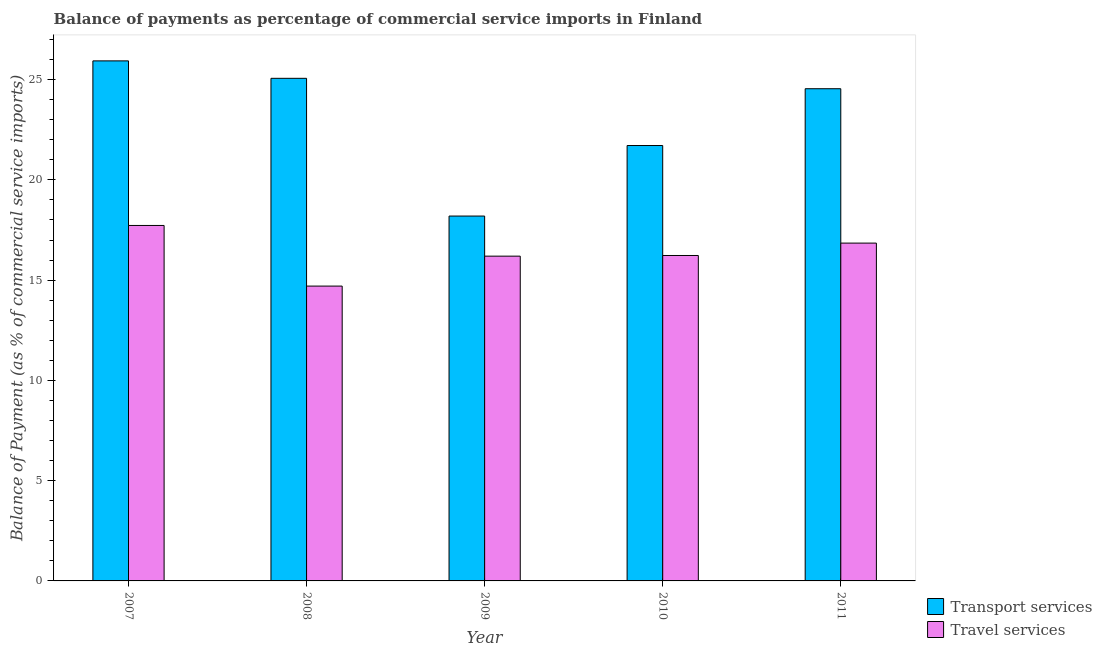How many bars are there on the 2nd tick from the right?
Your answer should be compact. 2. What is the label of the 4th group of bars from the left?
Give a very brief answer. 2010. In how many cases, is the number of bars for a given year not equal to the number of legend labels?
Offer a terse response. 0. What is the balance of payments of transport services in 2011?
Make the answer very short. 24.54. Across all years, what is the maximum balance of payments of travel services?
Ensure brevity in your answer.  17.73. Across all years, what is the minimum balance of payments of transport services?
Make the answer very short. 18.19. In which year was the balance of payments of travel services maximum?
Provide a short and direct response. 2007. What is the total balance of payments of travel services in the graph?
Give a very brief answer. 81.7. What is the difference between the balance of payments of transport services in 2010 and that in 2011?
Offer a very short reply. -2.83. What is the difference between the balance of payments of travel services in 2007 and the balance of payments of transport services in 2009?
Your answer should be very brief. 1.53. What is the average balance of payments of travel services per year?
Provide a short and direct response. 16.34. In how many years, is the balance of payments of transport services greater than 12 %?
Ensure brevity in your answer.  5. What is the ratio of the balance of payments of transport services in 2007 to that in 2010?
Keep it short and to the point. 1.19. What is the difference between the highest and the second highest balance of payments of transport services?
Give a very brief answer. 0.87. What is the difference between the highest and the lowest balance of payments of transport services?
Your answer should be compact. 7.74. In how many years, is the balance of payments of travel services greater than the average balance of payments of travel services taken over all years?
Offer a very short reply. 2. What does the 1st bar from the left in 2009 represents?
Ensure brevity in your answer.  Transport services. What does the 1st bar from the right in 2007 represents?
Your answer should be very brief. Travel services. What is the difference between two consecutive major ticks on the Y-axis?
Keep it short and to the point. 5. Are the values on the major ticks of Y-axis written in scientific E-notation?
Provide a short and direct response. No. Does the graph contain any zero values?
Provide a short and direct response. No. Does the graph contain grids?
Provide a succinct answer. No. Where does the legend appear in the graph?
Provide a short and direct response. Bottom right. How many legend labels are there?
Provide a short and direct response. 2. How are the legend labels stacked?
Offer a terse response. Vertical. What is the title of the graph?
Provide a succinct answer. Balance of payments as percentage of commercial service imports in Finland. Does "Ages 15-24" appear as one of the legend labels in the graph?
Offer a terse response. No. What is the label or title of the X-axis?
Offer a very short reply. Year. What is the label or title of the Y-axis?
Provide a succinct answer. Balance of Payment (as % of commercial service imports). What is the Balance of Payment (as % of commercial service imports) in Transport services in 2007?
Provide a short and direct response. 25.93. What is the Balance of Payment (as % of commercial service imports) of Travel services in 2007?
Your answer should be very brief. 17.73. What is the Balance of Payment (as % of commercial service imports) in Transport services in 2008?
Provide a succinct answer. 25.06. What is the Balance of Payment (as % of commercial service imports) of Travel services in 2008?
Offer a very short reply. 14.7. What is the Balance of Payment (as % of commercial service imports) in Transport services in 2009?
Give a very brief answer. 18.19. What is the Balance of Payment (as % of commercial service imports) of Travel services in 2009?
Your answer should be very brief. 16.2. What is the Balance of Payment (as % of commercial service imports) in Transport services in 2010?
Provide a succinct answer. 21.71. What is the Balance of Payment (as % of commercial service imports) in Travel services in 2010?
Ensure brevity in your answer.  16.23. What is the Balance of Payment (as % of commercial service imports) in Transport services in 2011?
Your answer should be compact. 24.54. What is the Balance of Payment (as % of commercial service imports) in Travel services in 2011?
Offer a terse response. 16.85. Across all years, what is the maximum Balance of Payment (as % of commercial service imports) in Transport services?
Provide a short and direct response. 25.93. Across all years, what is the maximum Balance of Payment (as % of commercial service imports) of Travel services?
Offer a terse response. 17.73. Across all years, what is the minimum Balance of Payment (as % of commercial service imports) of Transport services?
Give a very brief answer. 18.19. Across all years, what is the minimum Balance of Payment (as % of commercial service imports) in Travel services?
Ensure brevity in your answer.  14.7. What is the total Balance of Payment (as % of commercial service imports) of Transport services in the graph?
Provide a short and direct response. 115.44. What is the total Balance of Payment (as % of commercial service imports) in Travel services in the graph?
Ensure brevity in your answer.  81.7. What is the difference between the Balance of Payment (as % of commercial service imports) in Transport services in 2007 and that in 2008?
Keep it short and to the point. 0.87. What is the difference between the Balance of Payment (as % of commercial service imports) of Travel services in 2007 and that in 2008?
Provide a short and direct response. 3.02. What is the difference between the Balance of Payment (as % of commercial service imports) of Transport services in 2007 and that in 2009?
Your answer should be very brief. 7.74. What is the difference between the Balance of Payment (as % of commercial service imports) of Travel services in 2007 and that in 2009?
Provide a succinct answer. 1.53. What is the difference between the Balance of Payment (as % of commercial service imports) of Transport services in 2007 and that in 2010?
Offer a very short reply. 4.22. What is the difference between the Balance of Payment (as % of commercial service imports) in Travel services in 2007 and that in 2010?
Give a very brief answer. 1.5. What is the difference between the Balance of Payment (as % of commercial service imports) of Transport services in 2007 and that in 2011?
Your response must be concise. 1.39. What is the difference between the Balance of Payment (as % of commercial service imports) in Travel services in 2007 and that in 2011?
Offer a terse response. 0.88. What is the difference between the Balance of Payment (as % of commercial service imports) in Transport services in 2008 and that in 2009?
Make the answer very short. 6.87. What is the difference between the Balance of Payment (as % of commercial service imports) of Travel services in 2008 and that in 2009?
Offer a very short reply. -1.49. What is the difference between the Balance of Payment (as % of commercial service imports) in Transport services in 2008 and that in 2010?
Make the answer very short. 3.35. What is the difference between the Balance of Payment (as % of commercial service imports) of Travel services in 2008 and that in 2010?
Offer a terse response. -1.53. What is the difference between the Balance of Payment (as % of commercial service imports) of Transport services in 2008 and that in 2011?
Keep it short and to the point. 0.52. What is the difference between the Balance of Payment (as % of commercial service imports) in Travel services in 2008 and that in 2011?
Offer a terse response. -2.14. What is the difference between the Balance of Payment (as % of commercial service imports) of Transport services in 2009 and that in 2010?
Ensure brevity in your answer.  -3.52. What is the difference between the Balance of Payment (as % of commercial service imports) in Travel services in 2009 and that in 2010?
Offer a very short reply. -0.03. What is the difference between the Balance of Payment (as % of commercial service imports) in Transport services in 2009 and that in 2011?
Make the answer very short. -6.35. What is the difference between the Balance of Payment (as % of commercial service imports) of Travel services in 2009 and that in 2011?
Make the answer very short. -0.65. What is the difference between the Balance of Payment (as % of commercial service imports) of Transport services in 2010 and that in 2011?
Your answer should be compact. -2.83. What is the difference between the Balance of Payment (as % of commercial service imports) of Travel services in 2010 and that in 2011?
Ensure brevity in your answer.  -0.62. What is the difference between the Balance of Payment (as % of commercial service imports) in Transport services in 2007 and the Balance of Payment (as % of commercial service imports) in Travel services in 2008?
Keep it short and to the point. 11.23. What is the difference between the Balance of Payment (as % of commercial service imports) of Transport services in 2007 and the Balance of Payment (as % of commercial service imports) of Travel services in 2009?
Offer a terse response. 9.74. What is the difference between the Balance of Payment (as % of commercial service imports) of Transport services in 2007 and the Balance of Payment (as % of commercial service imports) of Travel services in 2010?
Keep it short and to the point. 9.7. What is the difference between the Balance of Payment (as % of commercial service imports) of Transport services in 2007 and the Balance of Payment (as % of commercial service imports) of Travel services in 2011?
Make the answer very short. 9.09. What is the difference between the Balance of Payment (as % of commercial service imports) of Transport services in 2008 and the Balance of Payment (as % of commercial service imports) of Travel services in 2009?
Your answer should be very brief. 8.87. What is the difference between the Balance of Payment (as % of commercial service imports) in Transport services in 2008 and the Balance of Payment (as % of commercial service imports) in Travel services in 2010?
Your response must be concise. 8.84. What is the difference between the Balance of Payment (as % of commercial service imports) in Transport services in 2008 and the Balance of Payment (as % of commercial service imports) in Travel services in 2011?
Offer a very short reply. 8.22. What is the difference between the Balance of Payment (as % of commercial service imports) in Transport services in 2009 and the Balance of Payment (as % of commercial service imports) in Travel services in 2010?
Offer a very short reply. 1.97. What is the difference between the Balance of Payment (as % of commercial service imports) in Transport services in 2009 and the Balance of Payment (as % of commercial service imports) in Travel services in 2011?
Make the answer very short. 1.35. What is the difference between the Balance of Payment (as % of commercial service imports) of Transport services in 2010 and the Balance of Payment (as % of commercial service imports) of Travel services in 2011?
Ensure brevity in your answer.  4.87. What is the average Balance of Payment (as % of commercial service imports) in Transport services per year?
Offer a very short reply. 23.09. What is the average Balance of Payment (as % of commercial service imports) of Travel services per year?
Your response must be concise. 16.34. In the year 2007, what is the difference between the Balance of Payment (as % of commercial service imports) of Transport services and Balance of Payment (as % of commercial service imports) of Travel services?
Offer a very short reply. 8.21. In the year 2008, what is the difference between the Balance of Payment (as % of commercial service imports) in Transport services and Balance of Payment (as % of commercial service imports) in Travel services?
Keep it short and to the point. 10.36. In the year 2009, what is the difference between the Balance of Payment (as % of commercial service imports) of Transport services and Balance of Payment (as % of commercial service imports) of Travel services?
Make the answer very short. 2. In the year 2010, what is the difference between the Balance of Payment (as % of commercial service imports) in Transport services and Balance of Payment (as % of commercial service imports) in Travel services?
Your answer should be compact. 5.48. In the year 2011, what is the difference between the Balance of Payment (as % of commercial service imports) in Transport services and Balance of Payment (as % of commercial service imports) in Travel services?
Give a very brief answer. 7.7. What is the ratio of the Balance of Payment (as % of commercial service imports) of Transport services in 2007 to that in 2008?
Ensure brevity in your answer.  1.03. What is the ratio of the Balance of Payment (as % of commercial service imports) of Travel services in 2007 to that in 2008?
Make the answer very short. 1.21. What is the ratio of the Balance of Payment (as % of commercial service imports) of Transport services in 2007 to that in 2009?
Your answer should be compact. 1.43. What is the ratio of the Balance of Payment (as % of commercial service imports) of Travel services in 2007 to that in 2009?
Offer a terse response. 1.09. What is the ratio of the Balance of Payment (as % of commercial service imports) of Transport services in 2007 to that in 2010?
Your answer should be very brief. 1.19. What is the ratio of the Balance of Payment (as % of commercial service imports) in Travel services in 2007 to that in 2010?
Provide a short and direct response. 1.09. What is the ratio of the Balance of Payment (as % of commercial service imports) in Transport services in 2007 to that in 2011?
Your answer should be compact. 1.06. What is the ratio of the Balance of Payment (as % of commercial service imports) in Travel services in 2007 to that in 2011?
Your answer should be very brief. 1.05. What is the ratio of the Balance of Payment (as % of commercial service imports) in Transport services in 2008 to that in 2009?
Your answer should be compact. 1.38. What is the ratio of the Balance of Payment (as % of commercial service imports) of Travel services in 2008 to that in 2009?
Your answer should be very brief. 0.91. What is the ratio of the Balance of Payment (as % of commercial service imports) in Transport services in 2008 to that in 2010?
Your answer should be compact. 1.15. What is the ratio of the Balance of Payment (as % of commercial service imports) in Travel services in 2008 to that in 2010?
Your response must be concise. 0.91. What is the ratio of the Balance of Payment (as % of commercial service imports) of Transport services in 2008 to that in 2011?
Give a very brief answer. 1.02. What is the ratio of the Balance of Payment (as % of commercial service imports) of Travel services in 2008 to that in 2011?
Your answer should be very brief. 0.87. What is the ratio of the Balance of Payment (as % of commercial service imports) in Transport services in 2009 to that in 2010?
Your answer should be compact. 0.84. What is the ratio of the Balance of Payment (as % of commercial service imports) of Travel services in 2009 to that in 2010?
Make the answer very short. 1. What is the ratio of the Balance of Payment (as % of commercial service imports) of Transport services in 2009 to that in 2011?
Provide a succinct answer. 0.74. What is the ratio of the Balance of Payment (as % of commercial service imports) of Travel services in 2009 to that in 2011?
Offer a very short reply. 0.96. What is the ratio of the Balance of Payment (as % of commercial service imports) in Transport services in 2010 to that in 2011?
Make the answer very short. 0.88. What is the ratio of the Balance of Payment (as % of commercial service imports) of Travel services in 2010 to that in 2011?
Your answer should be very brief. 0.96. What is the difference between the highest and the second highest Balance of Payment (as % of commercial service imports) in Transport services?
Ensure brevity in your answer.  0.87. What is the difference between the highest and the lowest Balance of Payment (as % of commercial service imports) in Transport services?
Make the answer very short. 7.74. What is the difference between the highest and the lowest Balance of Payment (as % of commercial service imports) of Travel services?
Provide a short and direct response. 3.02. 